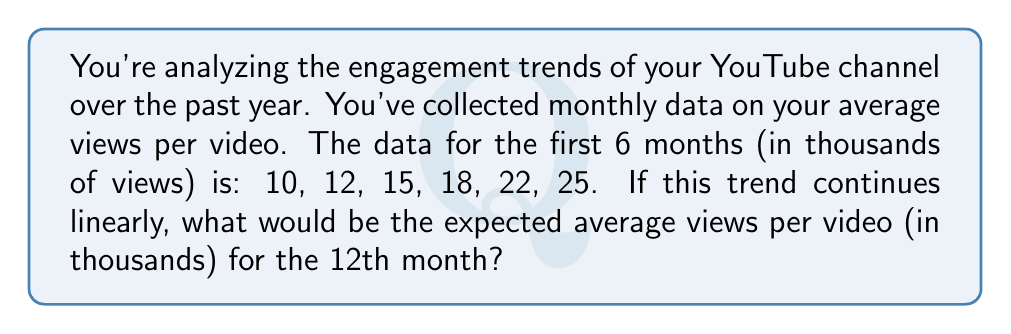Can you answer this question? To solve this problem, we'll use linear regression to analyze the trend and predict future values. Here's a step-by-step approach:

1) First, let's define our variables:
   $x$ represents the month number (1 to 6)
   $y$ represents the average views in thousands

2) We need to calculate the slope $(m)$ of the line. The formula for the slope is:

   $$m = \frac{n\sum xy - \sum x \sum y}{n\sum x^2 - (\sum x)^2}$$

   where $n$ is the number of data points (6 in this case)

3) Let's calculate the necessary sums:
   $\sum x = 1 + 2 + 3 + 4 + 5 + 6 = 21$
   $\sum y = 10 + 12 + 15 + 18 + 22 + 25 = 102$
   $\sum xy = 1(10) + 2(12) + 3(15) + 4(18) + 5(22) + 6(25) = 441$
   $\sum x^2 = 1^2 + 2^2 + 3^2 + 4^2 + 5^2 + 6^2 = 91$

4) Now we can calculate the slope:

   $$m = \frac{6(441) - 21(102)}{6(91) - 21^2} = \frac{2646 - 2142}{546 - 441} = \frac{504}{105} = 4.8$$

5) Next, we need to find the y-intercept $(b)$ using the formula:

   $$b = \bar{y} - m\bar{x}$$

   where $\bar{x}$ and $\bar{y}$ are the means of $x$ and $y$ respectively

6) Calculate the means:
   $\bar{x} = 21 / 6 = 3.5$
   $\bar{y} = 102 / 6 = 17$

7) Now we can calculate $b$:

   $$b = 17 - 4.8(3.5) = 17 - 16.8 = 0.2$$

8) Our linear equation is therefore:

   $$y = 4.8x + 0.2$$

9) To find the expected views for the 12th month, we substitute $x = 12$:

   $$y = 4.8(12) + 0.2 = 57.8$$

Therefore, the expected average views per video for the 12th month would be 57.8 thousand.
Answer: 57.8 thousand views 